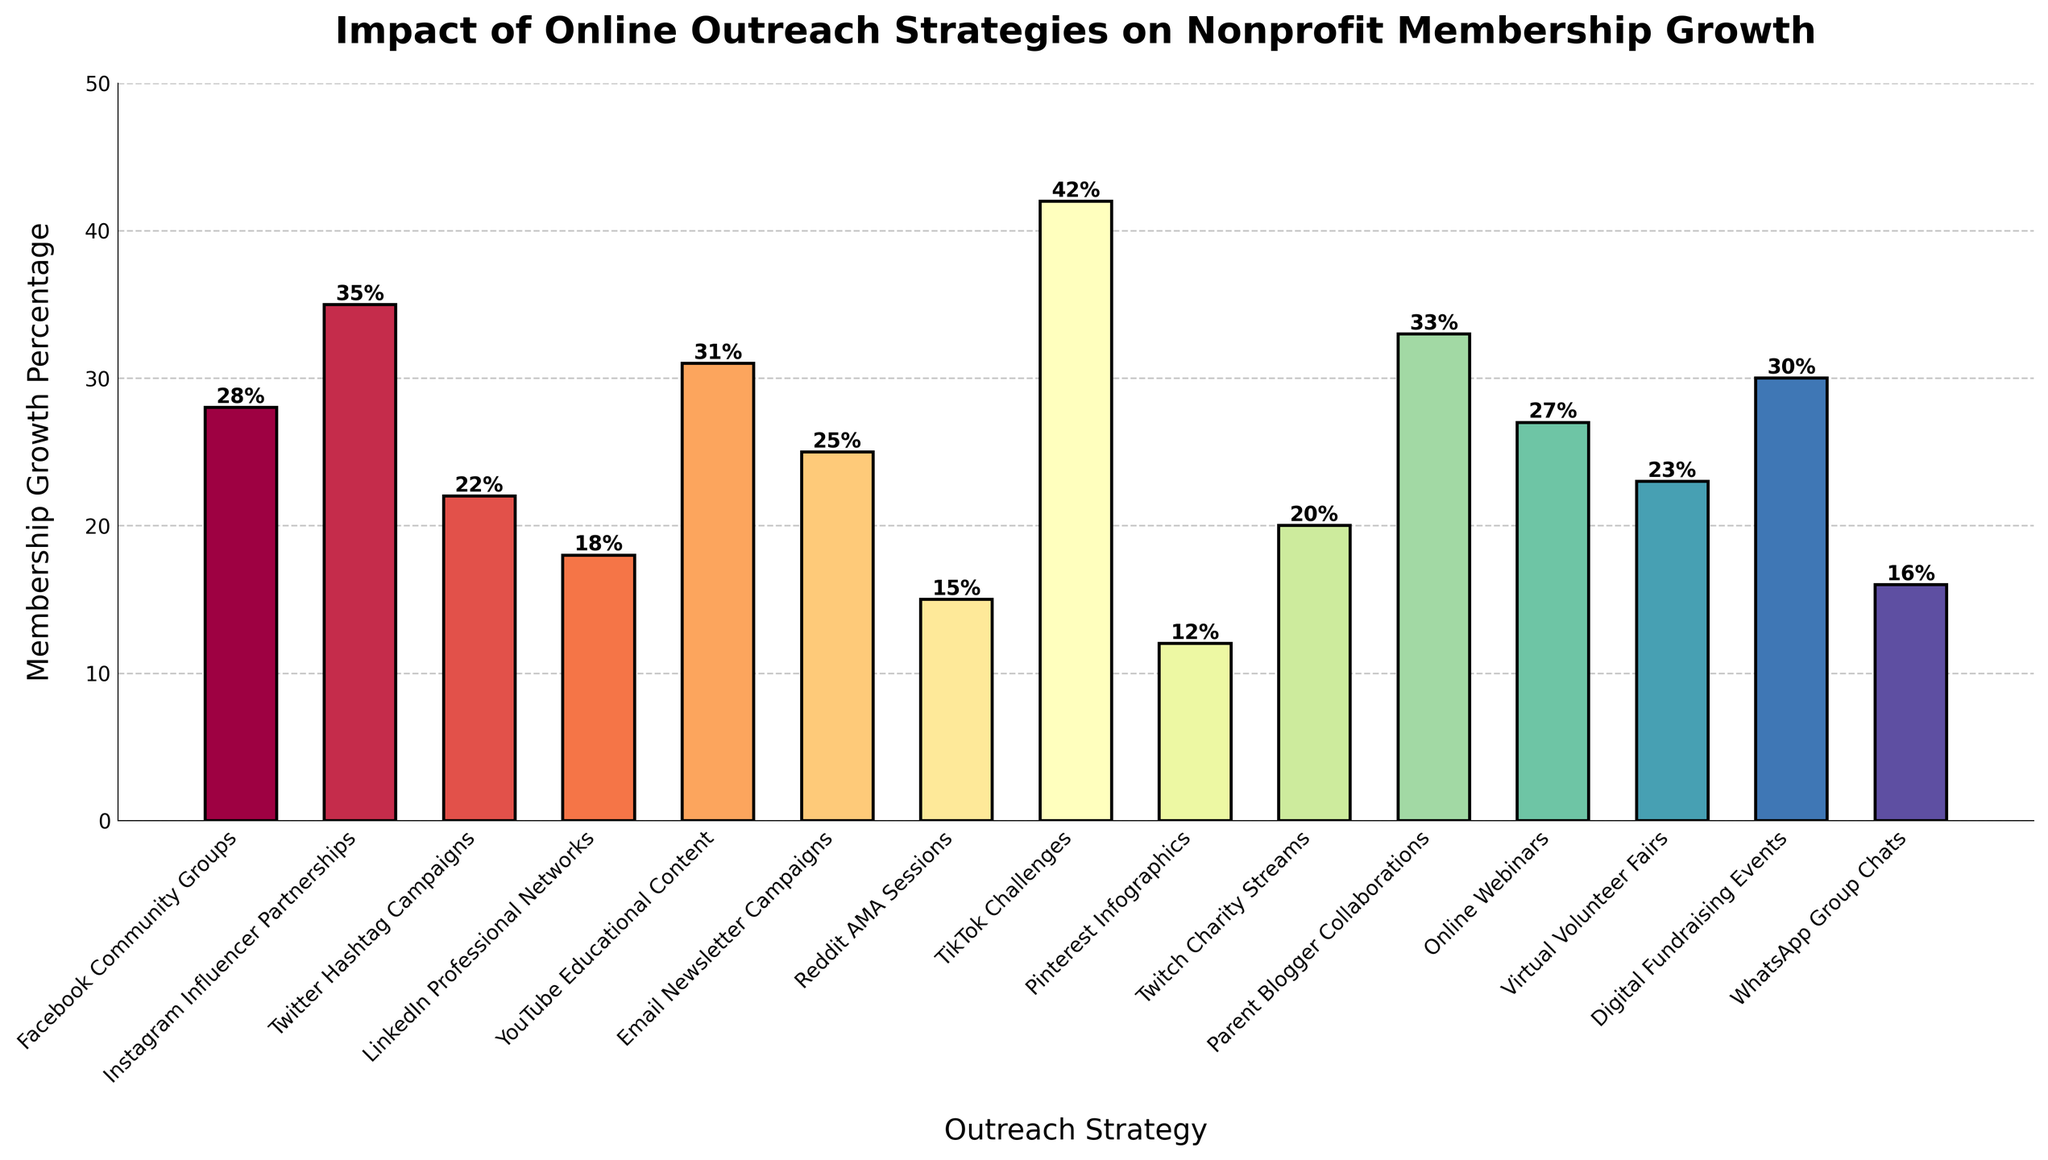What is the outreach strategy with the highest membership growth percentage? Scan the heights of all bars and identify the tallest one. TikTok Challenges have the highest bar with a 42% growth.
Answer: TikTok Challenges What is the difference in membership growth between Facebook Community Groups and YouTube Educational Content? Identify the heights of the bars for Facebook Community Groups (28%) and YouTube Educational Content (31%), then subtract the smaller value from the larger. 31% - 28% = 3%.
Answer: 3% Which two strategies have the closest membership growth percentages, and what are their values? Review all bars and identify pairs of bars with similar heights. Parent Blogger Collaborations (33%) and Instagram Influencer Partnerships (35%) are visually the closest.
Answer: Parent Blogger Collaborations (33%) and Instagram Influencer Partnerships (35%) What is the total membership growth percentage of the top three strategies? Identify the bars with the top three highest values: TikTok Challenges (42%), Instagram Influencer Partnerships (35%), and YouTube Educational Content (31%). Add these values together: 42% + 35% + 31% = 108%.
Answer: 108% How many strategies have a membership growth percentage of 20% or below? Count the number of bars with heights at 20% or less. These bars are: Reddit AMA Sessions (15%), Pinterest Infographics (12%), and Twitch Charity Streams (20%). There are three such bars.
Answer: 3 Which strategy has a greater membership growth percentage, Digital Fundraising Events or Online Webinars? Compare the heights of the bars for Digital Fundraising Events (30%) and Online Webinars (27%). Digital Fundraising Events is higher.
Answer: Digital Fundraising Events What is the average membership growth percentage for all strategies? Sum all the bars’ heights and divide by the number of bars. Sum: 28% + 35% + 22% + 18% + 31% + 25% + 15% + 42% + 12% + 20% + 33% + 27% + 23% + 30% + 16% = 377%. The number of bars (strategies) is 15. Average: 377 / 15 ≈ 25.1%.
Answer: ~25.1% 